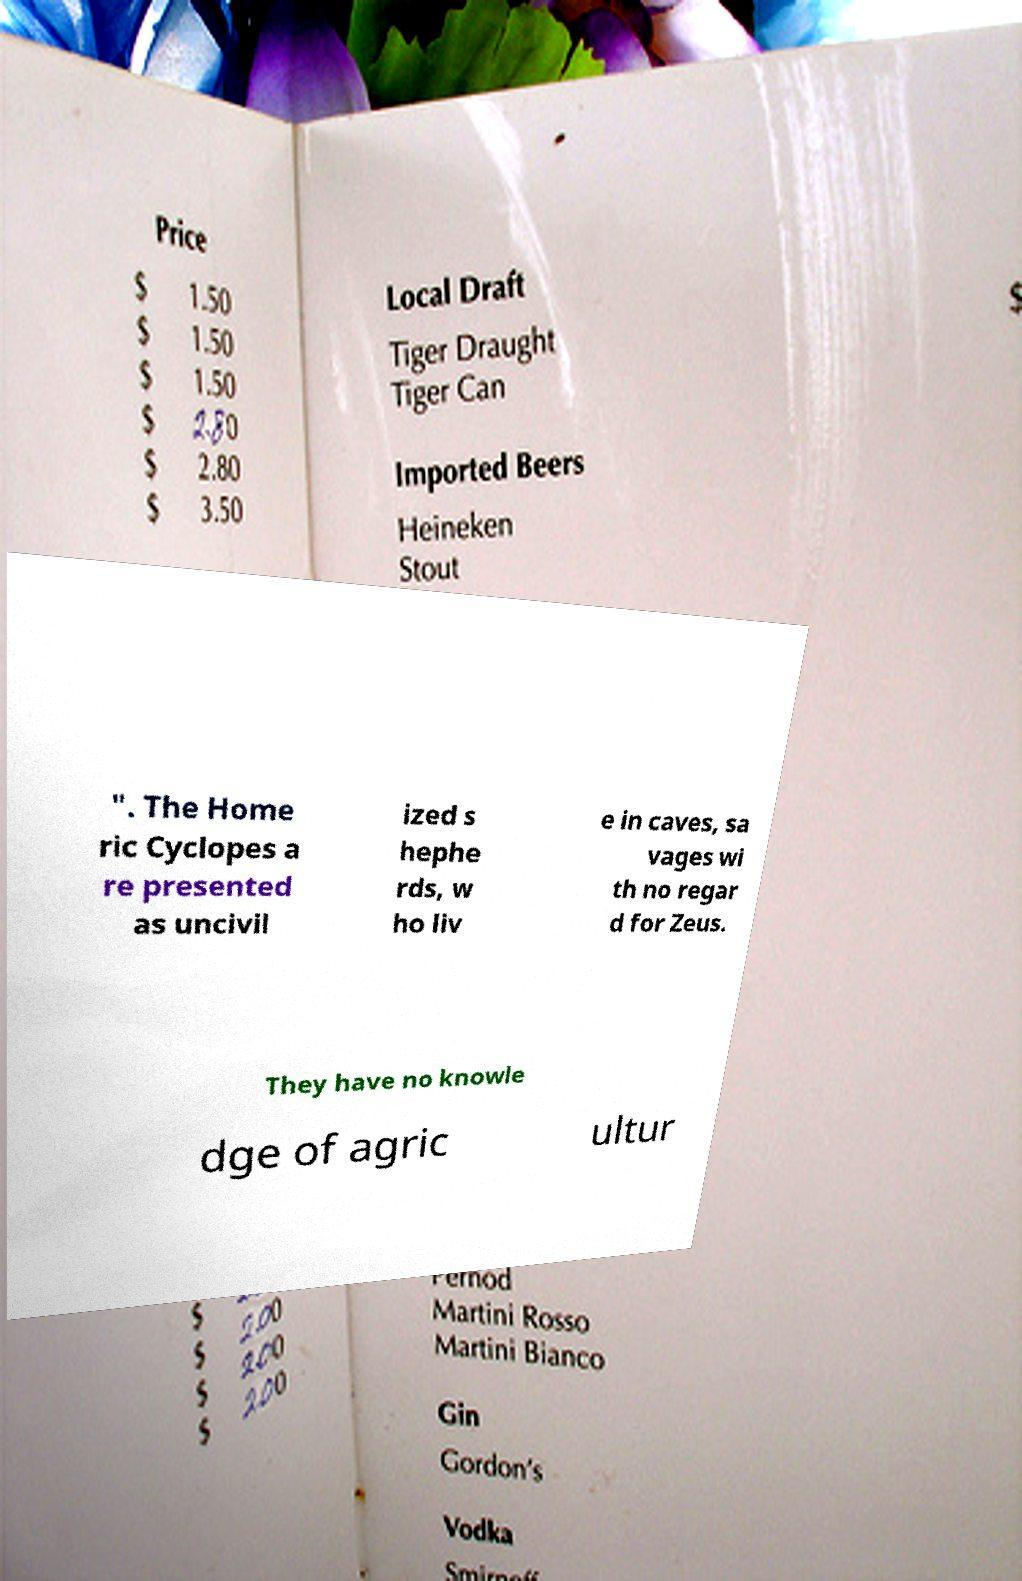What messages or text are displayed in this image? I need them in a readable, typed format. ". The Home ric Cyclopes a re presented as uncivil ized s hephe rds, w ho liv e in caves, sa vages wi th no regar d for Zeus. They have no knowle dge of agric ultur 